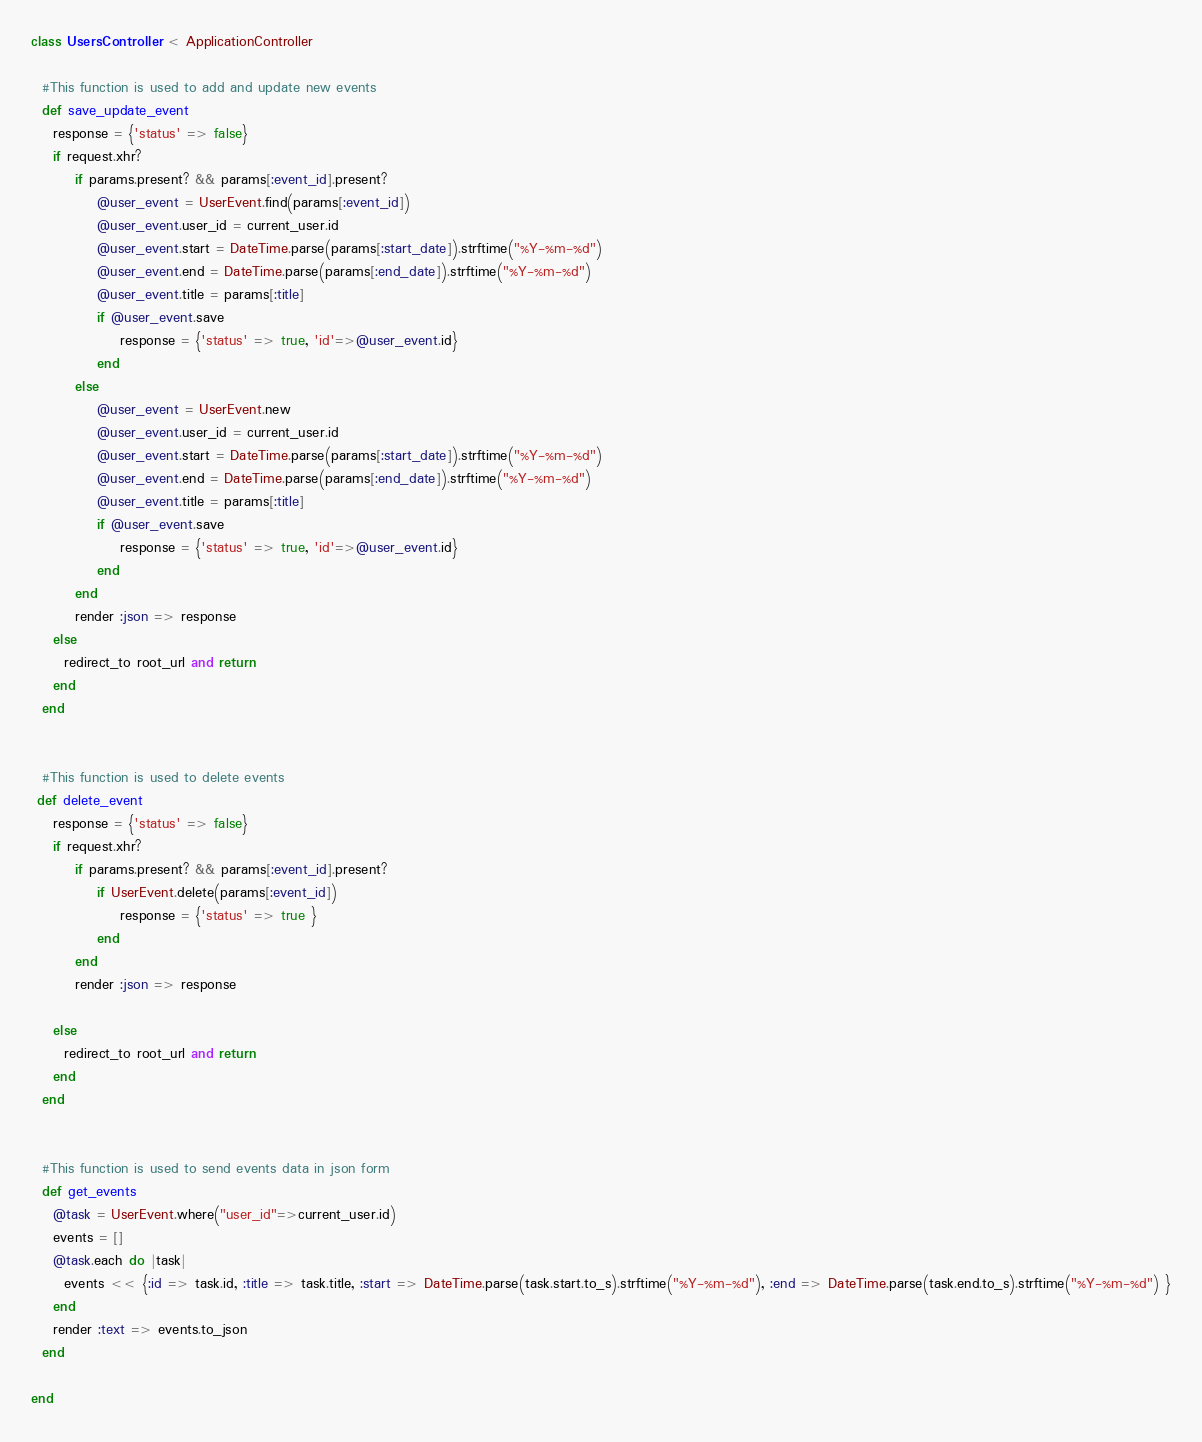Convert code to text. <code><loc_0><loc_0><loc_500><loc_500><_Ruby_>class UsersController < ApplicationController

  #This function is used to add and update new events
  def save_update_event    
    response = {'status' => false}
    if request.xhr?     
		if params.present? && params[:event_id].present?
			@user_event = UserEvent.find(params[:event_id])
			@user_event.user_id = current_user.id
			@user_event.start = DateTime.parse(params[:start_date]).strftime("%Y-%m-%d")
			@user_event.end = DateTime.parse(params[:end_date]).strftime("%Y-%m-%d")
			@user_event.title = params[:title]
			if @user_event.save
				response = {'status' => true, 'id'=>@user_event.id}
			end
		else		
			@user_event = UserEvent.new
			@user_event.user_id = current_user.id
			@user_event.start = DateTime.parse(params[:start_date]).strftime("%Y-%m-%d")
			@user_event.end = DateTime.parse(params[:end_date]).strftime("%Y-%m-%d")
			@user_event.title = params[:title]
			if @user_event.save
				response = {'status' => true, 'id'=>@user_event.id}
			end				
		end		
		render :json => response 	
    else
      redirect_to root_url and return
    end	
  end  
  
  
  #This function is used to delete events
 def delete_event    
    response = {'status' => false}
    if request.xhr?          
		if params.present? && params[:event_id].present?			 			
			if UserEvent.delete(params[:event_id])
				response = {'status' => true }
			end					
		end		
		render :json => response 
	
    else
      redirect_to root_url and return
    end	
  end 
  
  
  #This function is used to send events data in json form
  def get_events			
    @task = UserEvent.where("user_id"=>current_user.id)
    events = []
    @task.each do |task|
      events << {:id => task.id, :title => task.title, :start => DateTime.parse(task.start.to_s).strftime("%Y-%m-%d"), :end => DateTime.parse(task.end.to_s).strftime("%Y-%m-%d") }
    end
    render :text => events.to_json   
  end  
  
end
</code> 